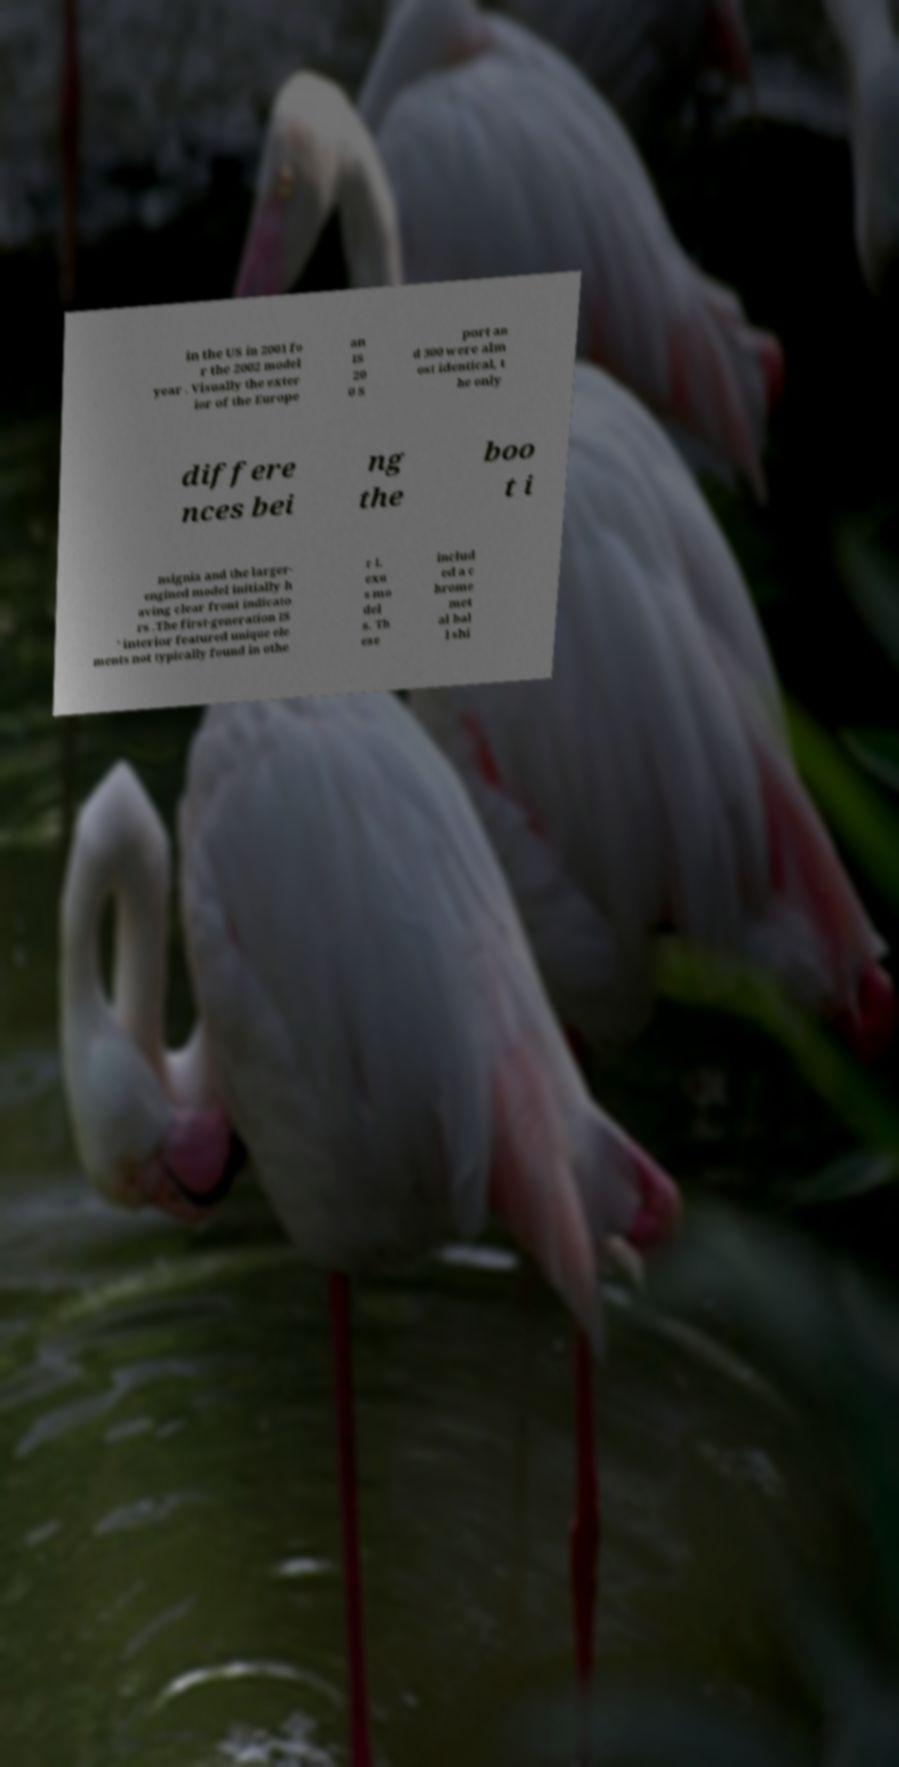Please identify and transcribe the text found in this image. in the US in 2001 fo r the 2002 model year . Visually the exter ior of the Europe an IS 20 0 S port an d 300 were alm ost identical, t he only differe nces bei ng the boo t i nsignia and the larger- engined model initially h aving clear front indicato rs .The first-generation IS ' interior featured unique ele ments not typically found in othe r L exu s mo del s. Th ese includ ed a c hrome met al bal l shi 